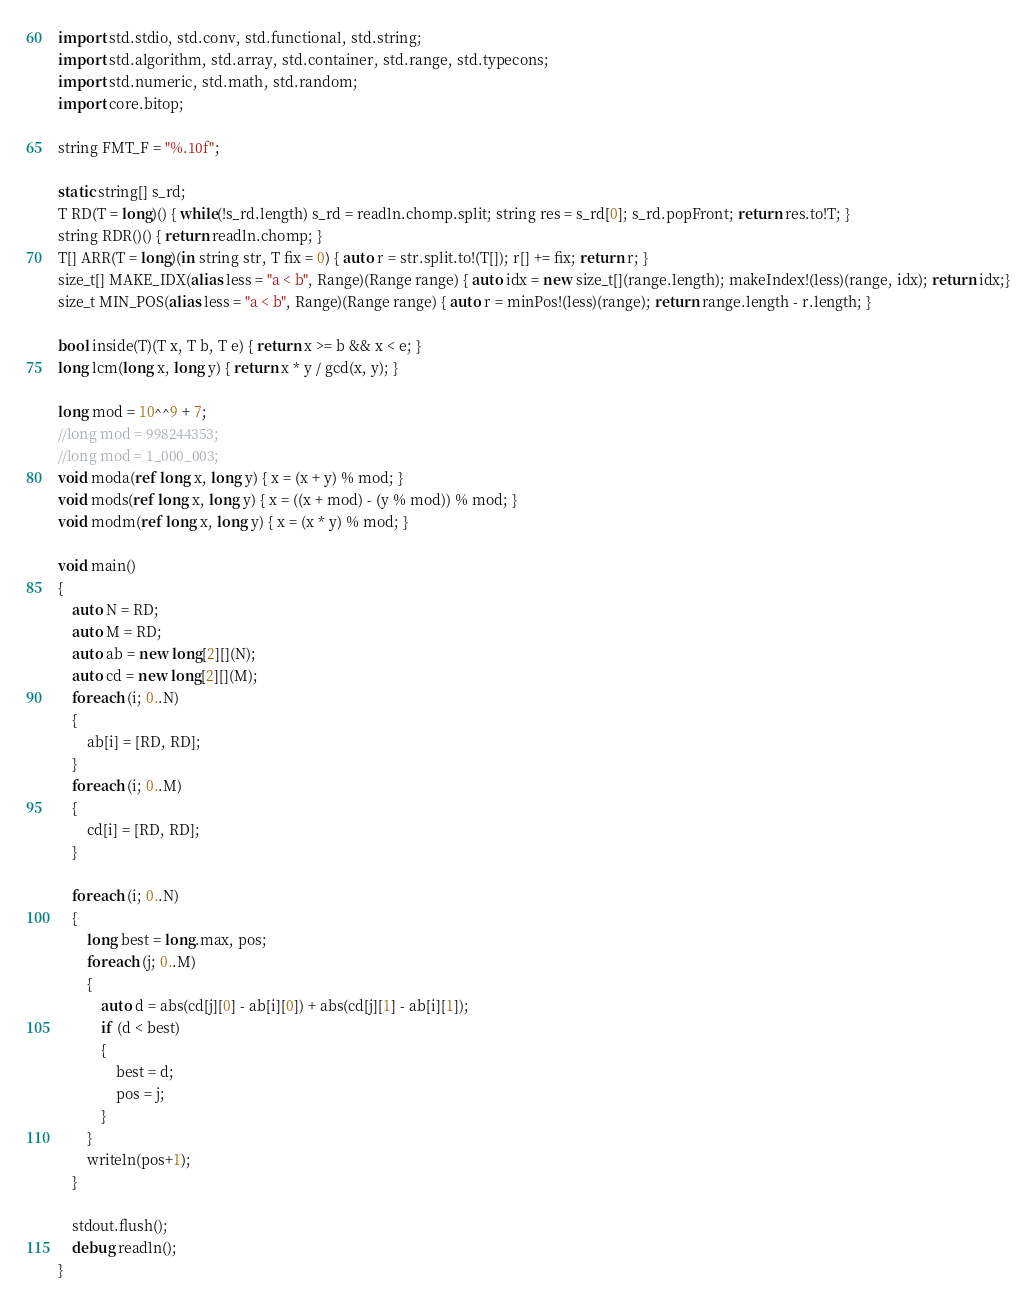<code> <loc_0><loc_0><loc_500><loc_500><_D_>import std.stdio, std.conv, std.functional, std.string;
import std.algorithm, std.array, std.container, std.range, std.typecons;
import std.numeric, std.math, std.random;
import core.bitop;

string FMT_F = "%.10f";

static string[] s_rd;
T RD(T = long)() { while(!s_rd.length) s_rd = readln.chomp.split; string res = s_rd[0]; s_rd.popFront; return res.to!T; }
string RDR()() { return readln.chomp; }
T[] ARR(T = long)(in string str, T fix = 0) { auto r = str.split.to!(T[]); r[] += fix; return r; }
size_t[] MAKE_IDX(alias less = "a < b", Range)(Range range) { auto idx = new size_t[](range.length); makeIndex!(less)(range, idx); return idx;}
size_t MIN_POS(alias less = "a < b", Range)(Range range) { auto r = minPos!(less)(range); return range.length - r.length; }

bool inside(T)(T x, T b, T e) { return x >= b && x < e; }
long lcm(long x, long y) { return x * y / gcd(x, y); }

long mod = 10^^9 + 7;
//long mod = 998244353;
//long mod = 1_000_003;
void moda(ref long x, long y) { x = (x + y) % mod; }
void mods(ref long x, long y) { x = ((x + mod) - (y % mod)) % mod; }
void modm(ref long x, long y) { x = (x * y) % mod; }

void main()
{
	auto N = RD;
	auto M = RD;
	auto ab = new long[2][](N);
	auto cd = new long[2][](M);
	foreach (i; 0..N)
	{
		ab[i] = [RD, RD];
	}
	foreach (i; 0..M)
	{
		cd[i] = [RD, RD];
	}

	foreach (i; 0..N)
	{
		long best = long.max, pos;
		foreach (j; 0..M)
		{
			auto d = abs(cd[j][0] - ab[i][0]) + abs(cd[j][1] - ab[i][1]);
			if (d < best)
			{
				best = d;
				pos = j;
			}
		}
		writeln(pos+1);
	}

	stdout.flush();
	debug readln();
}</code> 